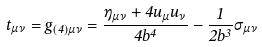<formula> <loc_0><loc_0><loc_500><loc_500>t _ { \mu \nu } = g _ { ( 4 ) \mu \nu } = \frac { \eta _ { \mu \nu } + 4 u _ { \mu } u _ { \nu } } { 4 b ^ { 4 } } - \frac { 1 } { 2 b ^ { 3 } } \sigma _ { \mu \nu }</formula> 